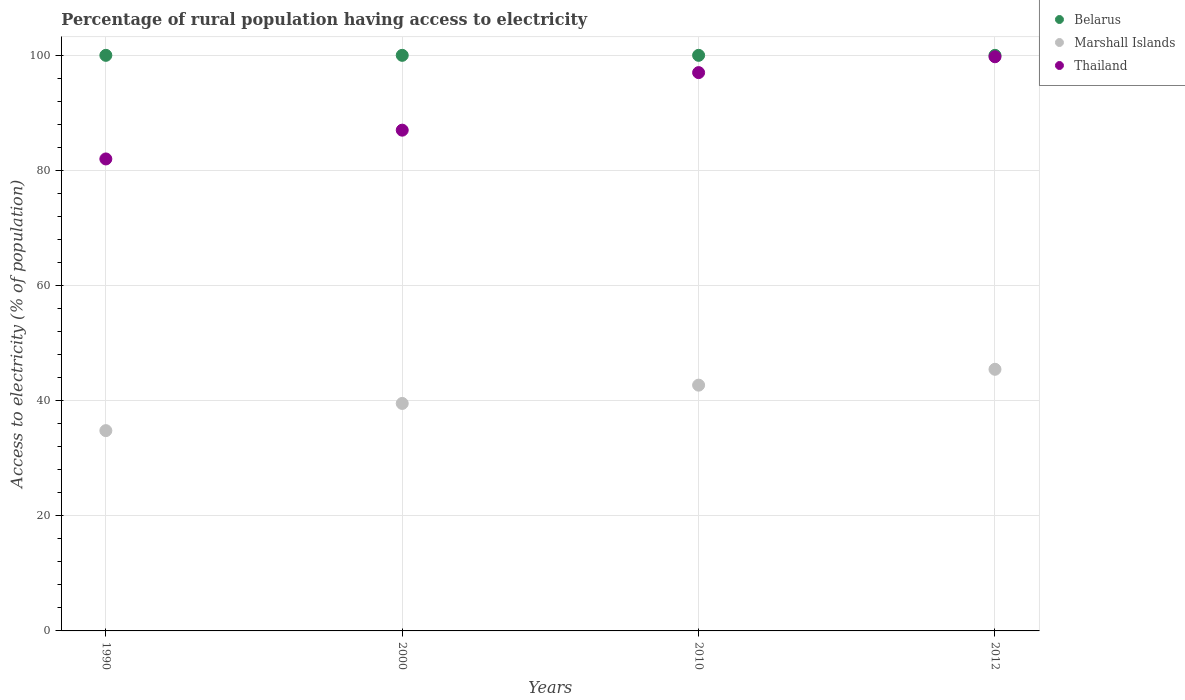Across all years, what is the maximum percentage of rural population having access to electricity in Thailand?
Your response must be concise. 99.75. Across all years, what is the minimum percentage of rural population having access to electricity in Belarus?
Provide a succinct answer. 100. In which year was the percentage of rural population having access to electricity in Belarus maximum?
Your answer should be compact. 1990. What is the total percentage of rural population having access to electricity in Marshall Islands in the graph?
Provide a succinct answer. 162.47. What is the difference between the percentage of rural population having access to electricity in Marshall Islands in 2010 and that in 2012?
Provide a succinct answer. -2.75. What is the difference between the percentage of rural population having access to electricity in Belarus in 2000 and the percentage of rural population having access to electricity in Marshall Islands in 1990?
Keep it short and to the point. 65.2. What is the average percentage of rural population having access to electricity in Thailand per year?
Provide a short and direct response. 91.44. In the year 2012, what is the difference between the percentage of rural population having access to electricity in Marshall Islands and percentage of rural population having access to electricity in Thailand?
Give a very brief answer. -54.3. In how many years, is the percentage of rural population having access to electricity in Thailand greater than 68 %?
Provide a short and direct response. 4. What is the ratio of the percentage of rural population having access to electricity in Marshall Islands in 2000 to that in 2012?
Offer a very short reply. 0.87. Is the percentage of rural population having access to electricity in Belarus in 2000 less than that in 2012?
Offer a terse response. No. What is the difference between the highest and the lowest percentage of rural population having access to electricity in Marshall Islands?
Provide a succinct answer. 10.66. Is the sum of the percentage of rural population having access to electricity in Belarus in 1990 and 2010 greater than the maximum percentage of rural population having access to electricity in Thailand across all years?
Make the answer very short. Yes. Does the percentage of rural population having access to electricity in Marshall Islands monotonically increase over the years?
Offer a terse response. Yes. Is the percentage of rural population having access to electricity in Thailand strictly less than the percentage of rural population having access to electricity in Belarus over the years?
Your response must be concise. Yes. How many dotlines are there?
Provide a short and direct response. 3. Does the graph contain any zero values?
Offer a very short reply. No. Where does the legend appear in the graph?
Your answer should be compact. Top right. How many legend labels are there?
Give a very brief answer. 3. What is the title of the graph?
Provide a succinct answer. Percentage of rural population having access to electricity. Does "Northern Mariana Islands" appear as one of the legend labels in the graph?
Give a very brief answer. No. What is the label or title of the Y-axis?
Your response must be concise. Access to electricity (% of population). What is the Access to electricity (% of population) in Belarus in 1990?
Ensure brevity in your answer.  100. What is the Access to electricity (% of population) in Marshall Islands in 1990?
Your answer should be compact. 34.8. What is the Access to electricity (% of population) in Marshall Islands in 2000?
Provide a succinct answer. 39.52. What is the Access to electricity (% of population) in Thailand in 2000?
Ensure brevity in your answer.  87. What is the Access to electricity (% of population) of Belarus in 2010?
Provide a short and direct response. 100. What is the Access to electricity (% of population) in Marshall Islands in 2010?
Your answer should be compact. 42.7. What is the Access to electricity (% of population) in Thailand in 2010?
Offer a terse response. 97. What is the Access to electricity (% of population) in Marshall Islands in 2012?
Provide a short and direct response. 45.45. What is the Access to electricity (% of population) in Thailand in 2012?
Your answer should be very brief. 99.75. Across all years, what is the maximum Access to electricity (% of population) in Marshall Islands?
Make the answer very short. 45.45. Across all years, what is the maximum Access to electricity (% of population) of Thailand?
Ensure brevity in your answer.  99.75. Across all years, what is the minimum Access to electricity (% of population) in Marshall Islands?
Your response must be concise. 34.8. Across all years, what is the minimum Access to electricity (% of population) in Thailand?
Offer a very short reply. 82. What is the total Access to electricity (% of population) in Marshall Islands in the graph?
Give a very brief answer. 162.47. What is the total Access to electricity (% of population) of Thailand in the graph?
Your answer should be compact. 365.75. What is the difference between the Access to electricity (% of population) of Marshall Islands in 1990 and that in 2000?
Your response must be concise. -4.72. What is the difference between the Access to electricity (% of population) in Belarus in 1990 and that in 2010?
Offer a terse response. 0. What is the difference between the Access to electricity (% of population) of Marshall Islands in 1990 and that in 2010?
Your response must be concise. -7.9. What is the difference between the Access to electricity (% of population) in Thailand in 1990 and that in 2010?
Provide a succinct answer. -15. What is the difference between the Access to electricity (% of population) of Belarus in 1990 and that in 2012?
Ensure brevity in your answer.  0. What is the difference between the Access to electricity (% of population) in Marshall Islands in 1990 and that in 2012?
Your answer should be compact. -10.66. What is the difference between the Access to electricity (% of population) of Thailand in 1990 and that in 2012?
Give a very brief answer. -17.75. What is the difference between the Access to electricity (% of population) in Belarus in 2000 and that in 2010?
Your answer should be compact. 0. What is the difference between the Access to electricity (% of population) in Marshall Islands in 2000 and that in 2010?
Ensure brevity in your answer.  -3.18. What is the difference between the Access to electricity (% of population) in Thailand in 2000 and that in 2010?
Your answer should be compact. -10. What is the difference between the Access to electricity (% of population) in Belarus in 2000 and that in 2012?
Offer a very short reply. 0. What is the difference between the Access to electricity (% of population) in Marshall Islands in 2000 and that in 2012?
Your answer should be very brief. -5.93. What is the difference between the Access to electricity (% of population) in Thailand in 2000 and that in 2012?
Your answer should be compact. -12.75. What is the difference between the Access to electricity (% of population) in Marshall Islands in 2010 and that in 2012?
Your answer should be compact. -2.75. What is the difference between the Access to electricity (% of population) in Thailand in 2010 and that in 2012?
Offer a terse response. -2.75. What is the difference between the Access to electricity (% of population) of Belarus in 1990 and the Access to electricity (% of population) of Marshall Islands in 2000?
Give a very brief answer. 60.48. What is the difference between the Access to electricity (% of population) of Belarus in 1990 and the Access to electricity (% of population) of Thailand in 2000?
Your answer should be compact. 13. What is the difference between the Access to electricity (% of population) in Marshall Islands in 1990 and the Access to electricity (% of population) in Thailand in 2000?
Your answer should be compact. -52.2. What is the difference between the Access to electricity (% of population) in Belarus in 1990 and the Access to electricity (% of population) in Marshall Islands in 2010?
Keep it short and to the point. 57.3. What is the difference between the Access to electricity (% of population) in Belarus in 1990 and the Access to electricity (% of population) in Thailand in 2010?
Provide a succinct answer. 3. What is the difference between the Access to electricity (% of population) in Marshall Islands in 1990 and the Access to electricity (% of population) in Thailand in 2010?
Provide a succinct answer. -62.2. What is the difference between the Access to electricity (% of population) in Belarus in 1990 and the Access to electricity (% of population) in Marshall Islands in 2012?
Keep it short and to the point. 54.55. What is the difference between the Access to electricity (% of population) in Belarus in 1990 and the Access to electricity (% of population) in Thailand in 2012?
Your answer should be compact. 0.25. What is the difference between the Access to electricity (% of population) of Marshall Islands in 1990 and the Access to electricity (% of population) of Thailand in 2012?
Provide a succinct answer. -64.96. What is the difference between the Access to electricity (% of population) of Belarus in 2000 and the Access to electricity (% of population) of Marshall Islands in 2010?
Make the answer very short. 57.3. What is the difference between the Access to electricity (% of population) of Belarus in 2000 and the Access to electricity (% of population) of Thailand in 2010?
Your response must be concise. 3. What is the difference between the Access to electricity (% of population) of Marshall Islands in 2000 and the Access to electricity (% of population) of Thailand in 2010?
Provide a succinct answer. -57.48. What is the difference between the Access to electricity (% of population) of Belarus in 2000 and the Access to electricity (% of population) of Marshall Islands in 2012?
Give a very brief answer. 54.55. What is the difference between the Access to electricity (% of population) in Belarus in 2000 and the Access to electricity (% of population) in Thailand in 2012?
Your answer should be very brief. 0.25. What is the difference between the Access to electricity (% of population) of Marshall Islands in 2000 and the Access to electricity (% of population) of Thailand in 2012?
Your answer should be compact. -60.23. What is the difference between the Access to electricity (% of population) of Belarus in 2010 and the Access to electricity (% of population) of Marshall Islands in 2012?
Provide a succinct answer. 54.55. What is the difference between the Access to electricity (% of population) in Belarus in 2010 and the Access to electricity (% of population) in Thailand in 2012?
Offer a terse response. 0.25. What is the difference between the Access to electricity (% of population) of Marshall Islands in 2010 and the Access to electricity (% of population) of Thailand in 2012?
Ensure brevity in your answer.  -57.05. What is the average Access to electricity (% of population) in Marshall Islands per year?
Give a very brief answer. 40.62. What is the average Access to electricity (% of population) of Thailand per year?
Provide a short and direct response. 91.44. In the year 1990, what is the difference between the Access to electricity (% of population) in Belarus and Access to electricity (% of population) in Marshall Islands?
Make the answer very short. 65.2. In the year 1990, what is the difference between the Access to electricity (% of population) in Belarus and Access to electricity (% of population) in Thailand?
Keep it short and to the point. 18. In the year 1990, what is the difference between the Access to electricity (% of population) in Marshall Islands and Access to electricity (% of population) in Thailand?
Your answer should be very brief. -47.2. In the year 2000, what is the difference between the Access to electricity (% of population) of Belarus and Access to electricity (% of population) of Marshall Islands?
Provide a short and direct response. 60.48. In the year 2000, what is the difference between the Access to electricity (% of population) of Marshall Islands and Access to electricity (% of population) of Thailand?
Ensure brevity in your answer.  -47.48. In the year 2010, what is the difference between the Access to electricity (% of population) of Belarus and Access to electricity (% of population) of Marshall Islands?
Offer a terse response. 57.3. In the year 2010, what is the difference between the Access to electricity (% of population) in Belarus and Access to electricity (% of population) in Thailand?
Make the answer very short. 3. In the year 2010, what is the difference between the Access to electricity (% of population) in Marshall Islands and Access to electricity (% of population) in Thailand?
Keep it short and to the point. -54.3. In the year 2012, what is the difference between the Access to electricity (% of population) in Belarus and Access to electricity (% of population) in Marshall Islands?
Your answer should be compact. 54.55. In the year 2012, what is the difference between the Access to electricity (% of population) in Belarus and Access to electricity (% of population) in Thailand?
Offer a very short reply. 0.25. In the year 2012, what is the difference between the Access to electricity (% of population) in Marshall Islands and Access to electricity (% of population) in Thailand?
Offer a very short reply. -54.3. What is the ratio of the Access to electricity (% of population) in Marshall Islands in 1990 to that in 2000?
Ensure brevity in your answer.  0.88. What is the ratio of the Access to electricity (% of population) in Thailand in 1990 to that in 2000?
Ensure brevity in your answer.  0.94. What is the ratio of the Access to electricity (% of population) of Marshall Islands in 1990 to that in 2010?
Provide a short and direct response. 0.81. What is the ratio of the Access to electricity (% of population) of Thailand in 1990 to that in 2010?
Offer a very short reply. 0.85. What is the ratio of the Access to electricity (% of population) in Belarus in 1990 to that in 2012?
Your answer should be compact. 1. What is the ratio of the Access to electricity (% of population) in Marshall Islands in 1990 to that in 2012?
Provide a succinct answer. 0.77. What is the ratio of the Access to electricity (% of population) of Thailand in 1990 to that in 2012?
Provide a succinct answer. 0.82. What is the ratio of the Access to electricity (% of population) in Belarus in 2000 to that in 2010?
Your answer should be very brief. 1. What is the ratio of the Access to electricity (% of population) of Marshall Islands in 2000 to that in 2010?
Provide a short and direct response. 0.93. What is the ratio of the Access to electricity (% of population) of Thailand in 2000 to that in 2010?
Your response must be concise. 0.9. What is the ratio of the Access to electricity (% of population) in Marshall Islands in 2000 to that in 2012?
Keep it short and to the point. 0.87. What is the ratio of the Access to electricity (% of population) in Thailand in 2000 to that in 2012?
Your answer should be very brief. 0.87. What is the ratio of the Access to electricity (% of population) of Marshall Islands in 2010 to that in 2012?
Your response must be concise. 0.94. What is the ratio of the Access to electricity (% of population) in Thailand in 2010 to that in 2012?
Provide a succinct answer. 0.97. What is the difference between the highest and the second highest Access to electricity (% of population) of Belarus?
Your response must be concise. 0. What is the difference between the highest and the second highest Access to electricity (% of population) in Marshall Islands?
Provide a succinct answer. 2.75. What is the difference between the highest and the second highest Access to electricity (% of population) in Thailand?
Give a very brief answer. 2.75. What is the difference between the highest and the lowest Access to electricity (% of population) of Belarus?
Give a very brief answer. 0. What is the difference between the highest and the lowest Access to electricity (% of population) of Marshall Islands?
Ensure brevity in your answer.  10.66. What is the difference between the highest and the lowest Access to electricity (% of population) of Thailand?
Ensure brevity in your answer.  17.75. 